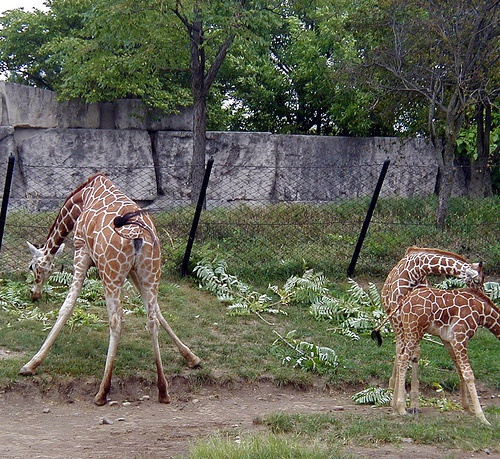Describe the objects in this image and their specific colors. I can see giraffe in white, gray, darkgray, and lightgray tones, giraffe in white, gray, maroon, and darkgray tones, and giraffe in white, gray, and darkgray tones in this image. 